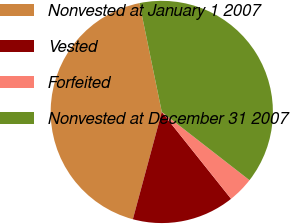<chart> <loc_0><loc_0><loc_500><loc_500><pie_chart><fcel>Nonvested at January 1 2007<fcel>Vested<fcel>Forfeited<fcel>Nonvested at December 31 2007<nl><fcel>42.58%<fcel>14.91%<fcel>3.76%<fcel>38.75%<nl></chart> 